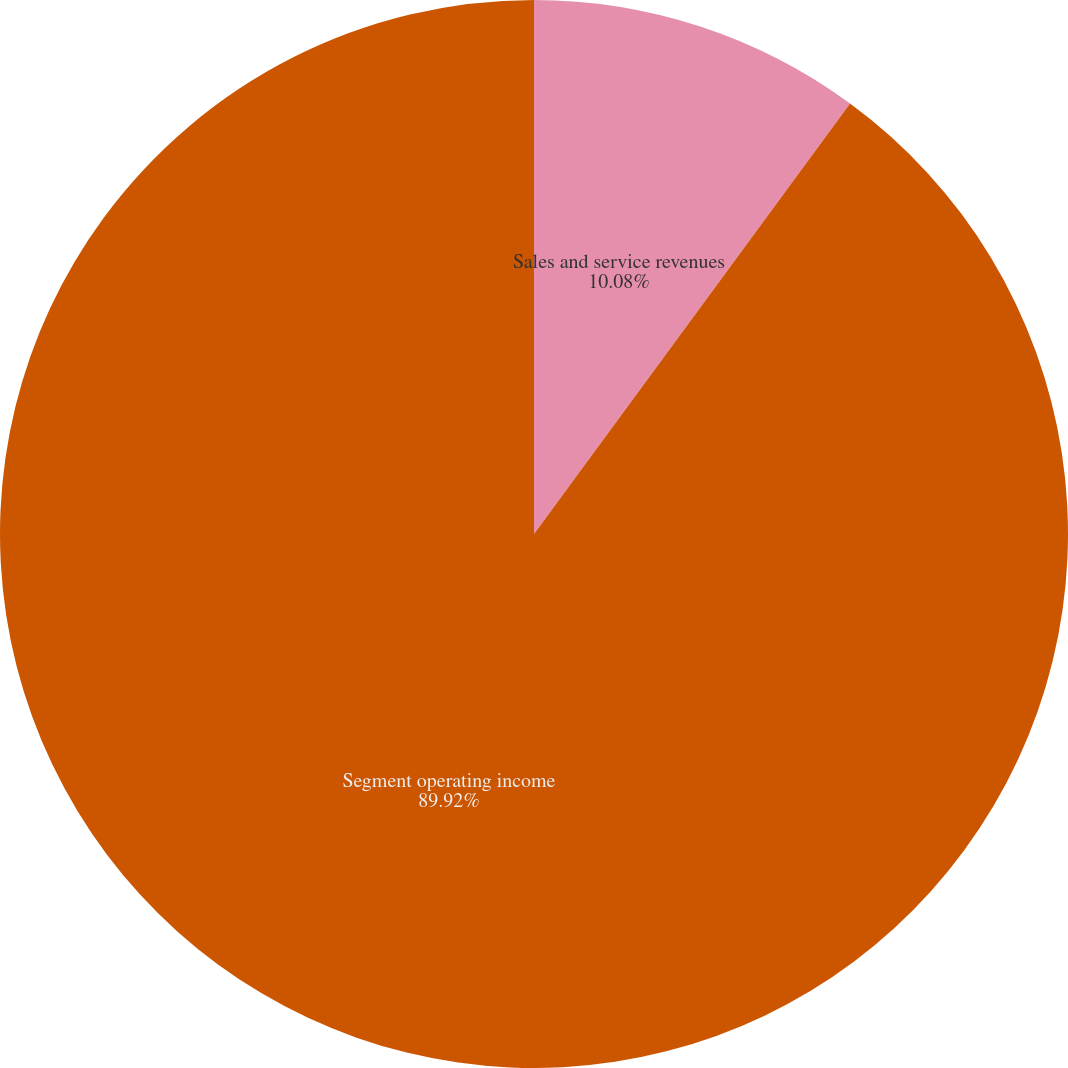Convert chart to OTSL. <chart><loc_0><loc_0><loc_500><loc_500><pie_chart><fcel>Sales and service revenues<fcel>Segment operating income<nl><fcel>10.08%<fcel>89.92%<nl></chart> 